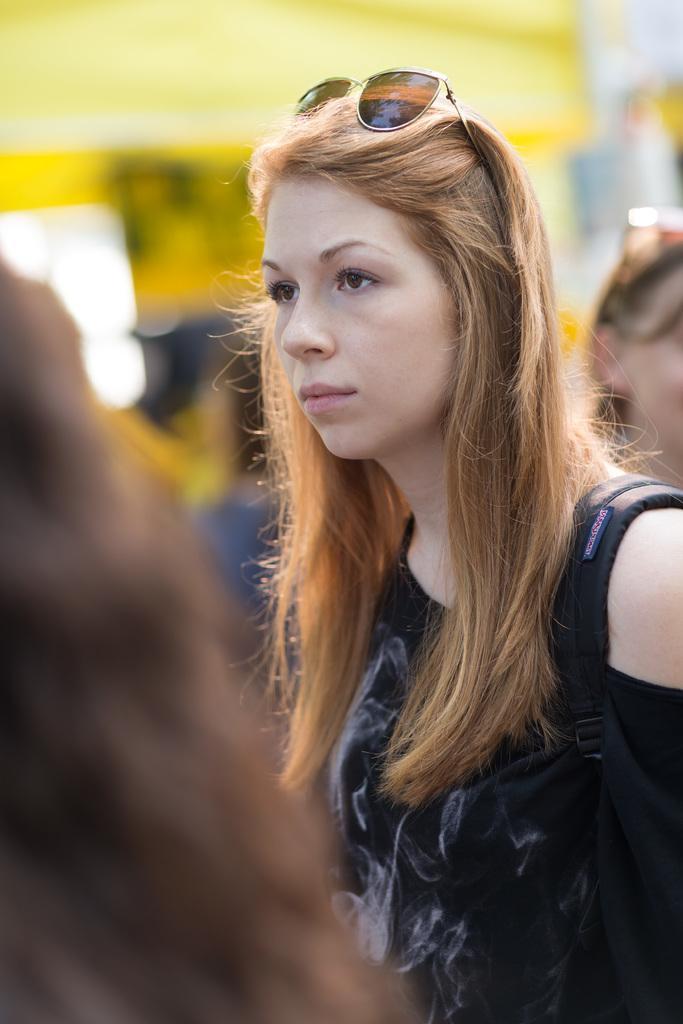Please provide a concise description of this image. On the right of this picture we can see a woman wearing black color dress, backpack and seems to be standing and we can see the group of persons. In the background there is a yellow color object and we can see some other objects. 